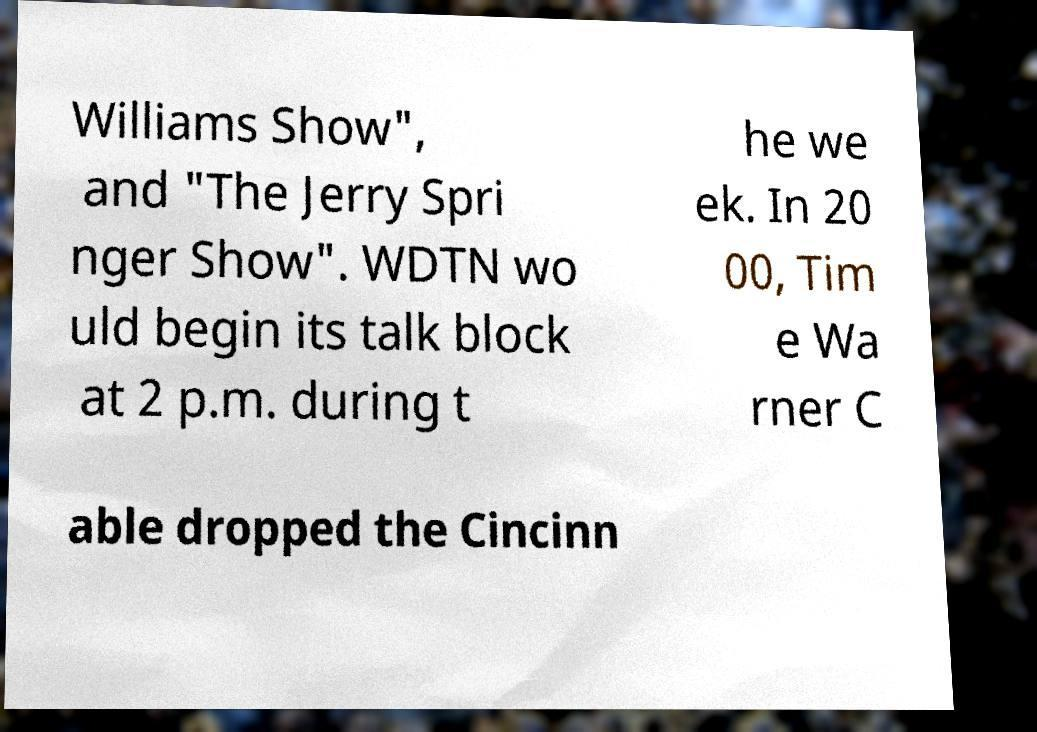For documentation purposes, I need the text within this image transcribed. Could you provide that? Williams Show", and "The Jerry Spri nger Show". WDTN wo uld begin its talk block at 2 p.m. during t he we ek. In 20 00, Tim e Wa rner C able dropped the Cincinn 